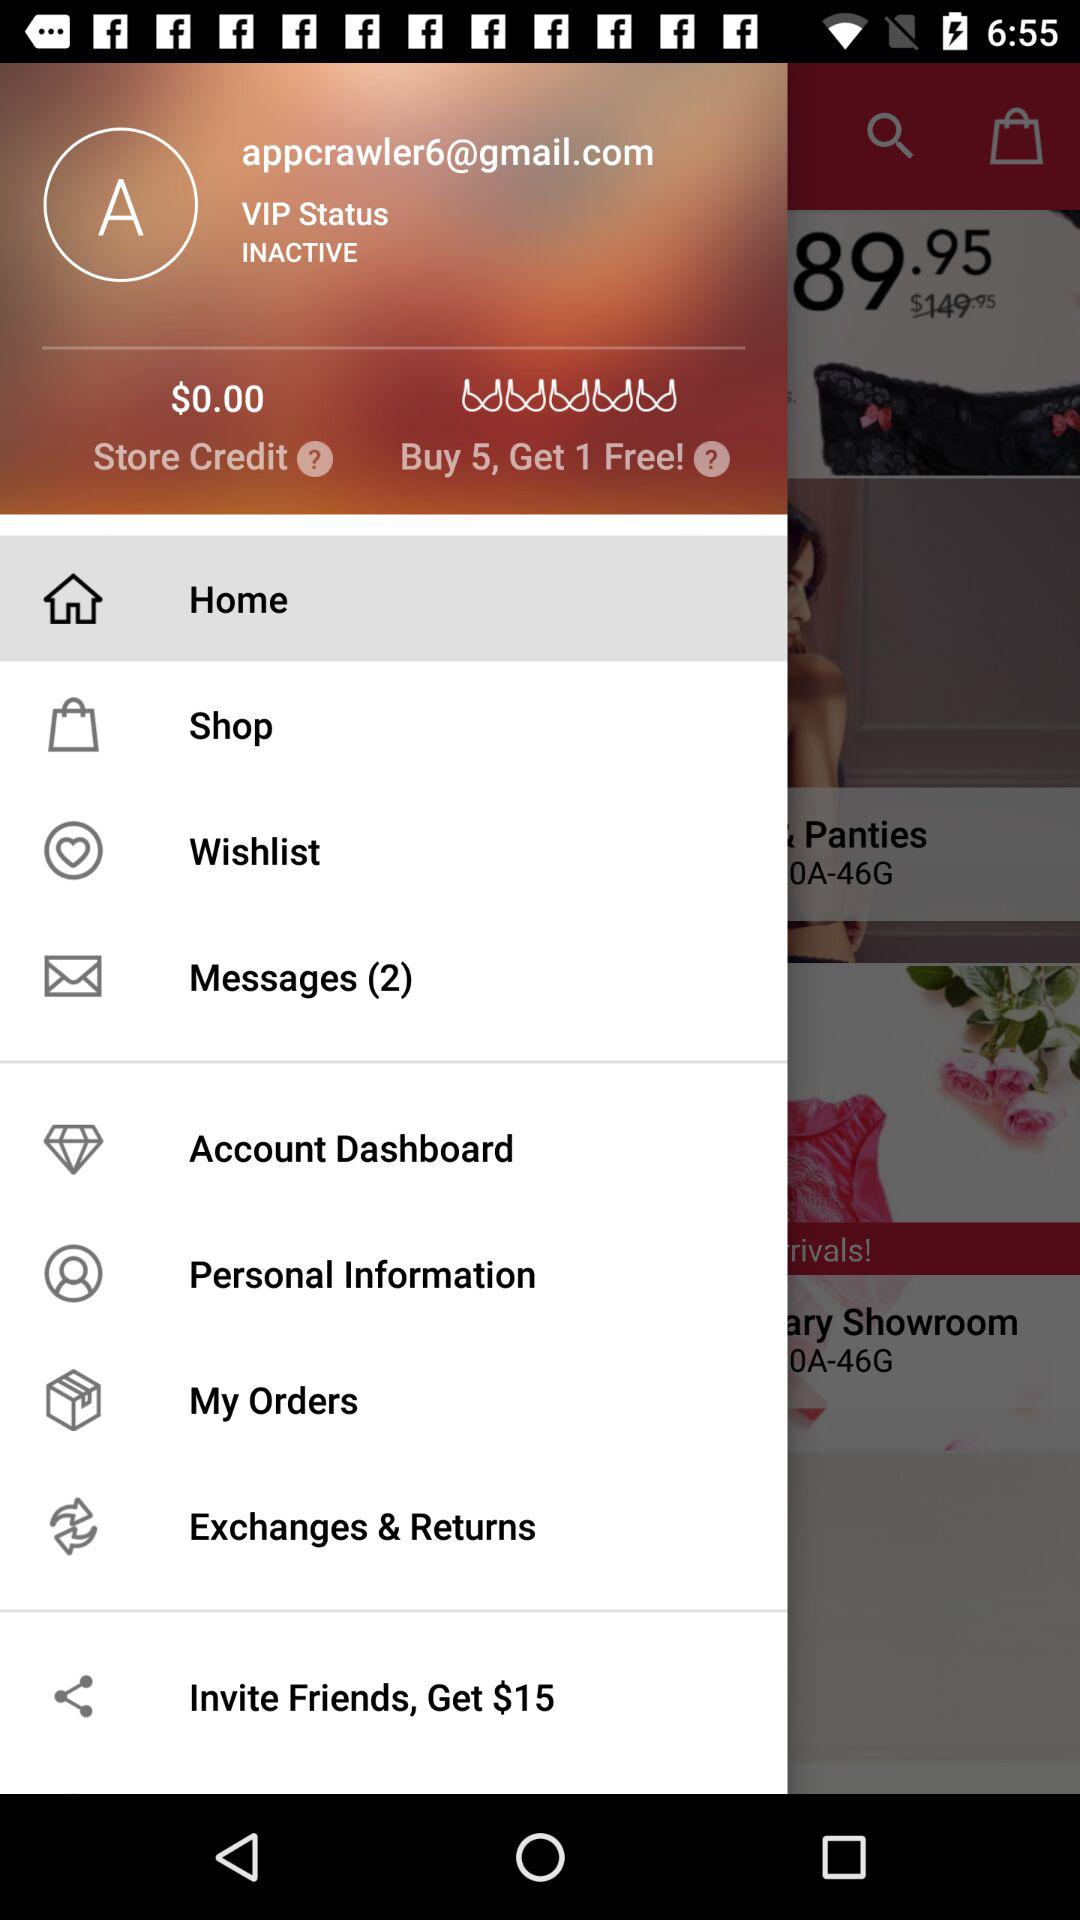What is the email address? The email address is appcrawler6@gmail.com. 